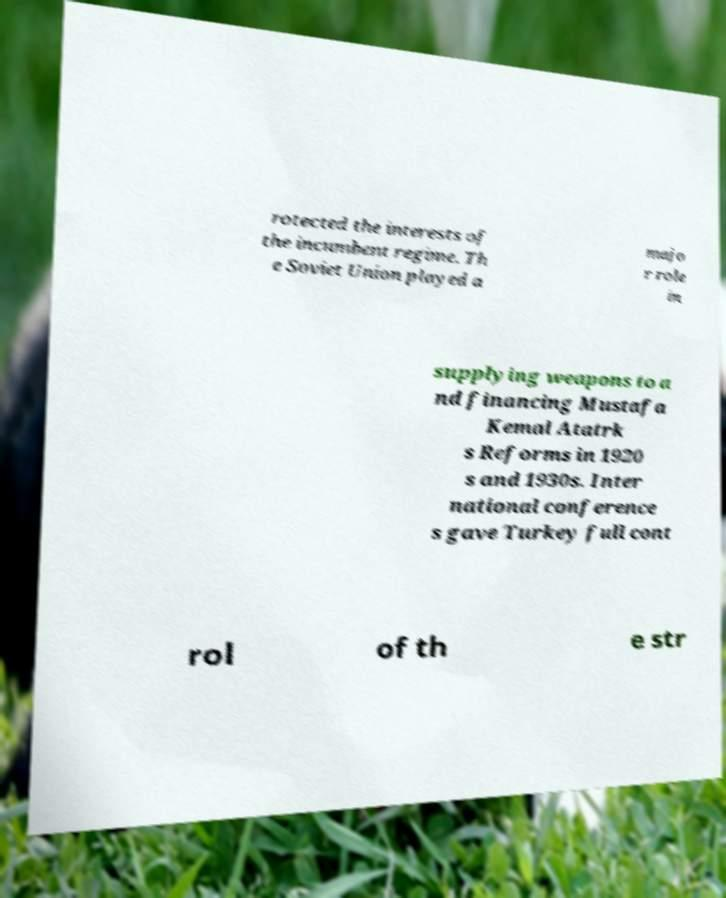Can you read and provide the text displayed in the image?This photo seems to have some interesting text. Can you extract and type it out for me? rotected the interests of the incumbent regime. Th e Soviet Union played a majo r role in supplying weapons to a nd financing Mustafa Kemal Atatrk s Reforms in 1920 s and 1930s. Inter national conference s gave Turkey full cont rol of th e str 